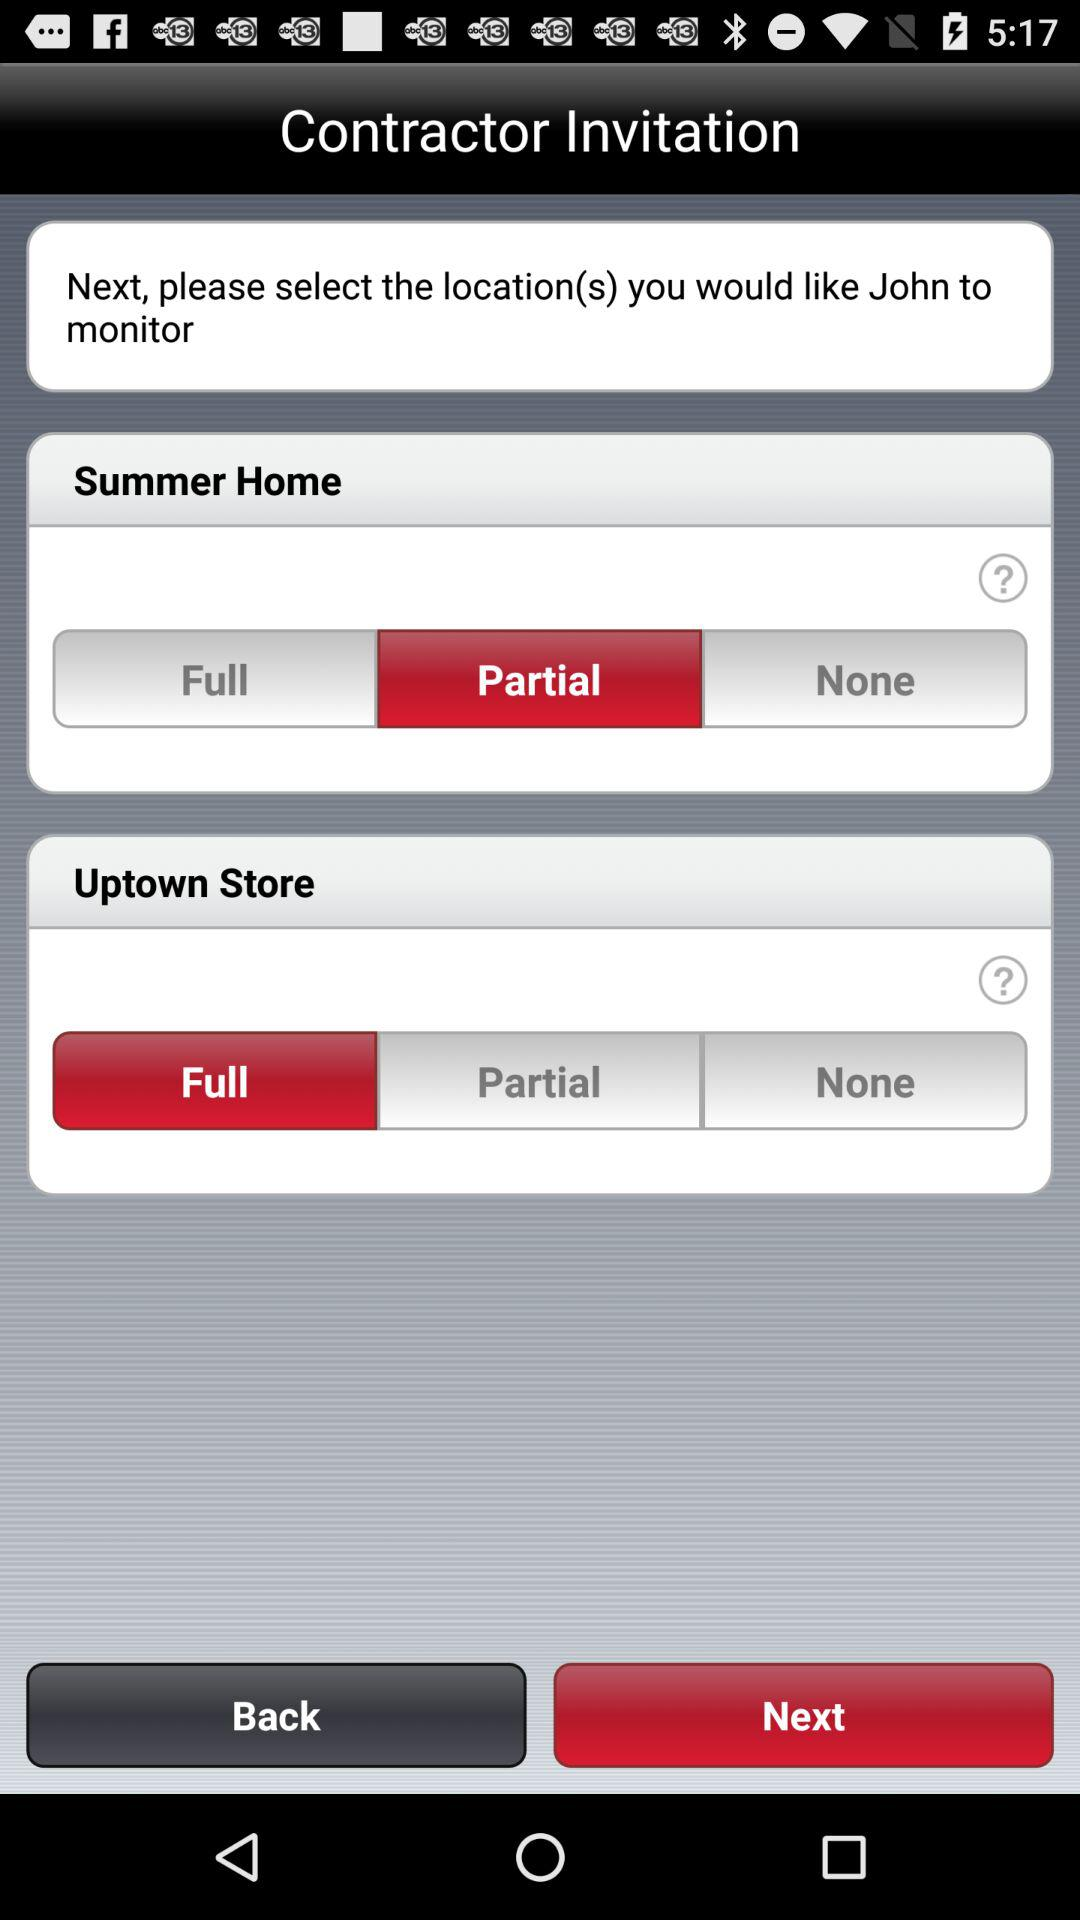Which "Uptown Store" option was selected? The selected "Uptown Store" option was "Full". 